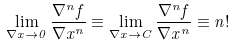Convert formula to latex. <formula><loc_0><loc_0><loc_500><loc_500>\lim _ { \nabla x \to 0 } \frac { \nabla ^ { n } f } { \nabla x ^ { n } } \equiv \lim _ { \nabla x \to C } \frac { \nabla ^ { n } f } { \nabla x ^ { n } } \equiv n !</formula> 